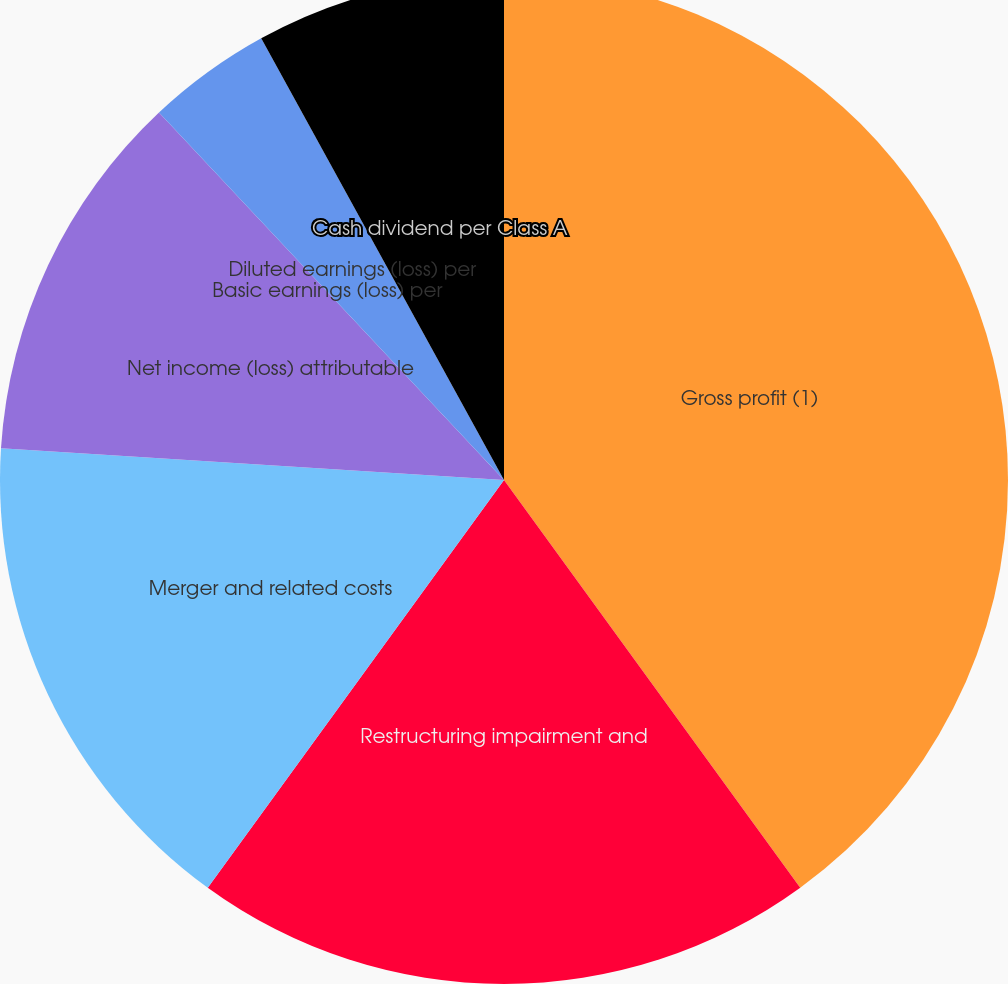Convert chart. <chart><loc_0><loc_0><loc_500><loc_500><pie_chart><fcel>Gross profit (1)<fcel>Restructuring impairment and<fcel>Merger and related costs<fcel>Net income (loss) attributable<fcel>Basic earnings (loss) per<fcel>Diluted earnings (loss) per<fcel>Cash dividend per Class A<nl><fcel>40.0%<fcel>20.0%<fcel>16.0%<fcel>12.0%<fcel>0.0%<fcel>4.0%<fcel>8.0%<nl></chart> 